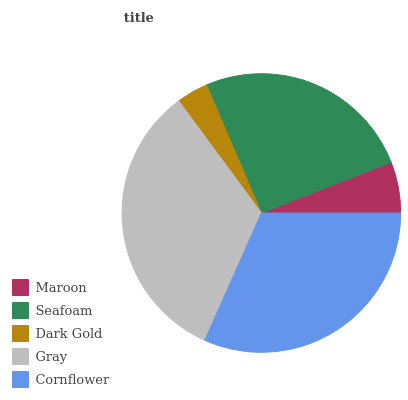Is Dark Gold the minimum?
Answer yes or no. Yes. Is Gray the maximum?
Answer yes or no. Yes. Is Seafoam the minimum?
Answer yes or no. No. Is Seafoam the maximum?
Answer yes or no. No. Is Seafoam greater than Maroon?
Answer yes or no. Yes. Is Maroon less than Seafoam?
Answer yes or no. Yes. Is Maroon greater than Seafoam?
Answer yes or no. No. Is Seafoam less than Maroon?
Answer yes or no. No. Is Seafoam the high median?
Answer yes or no. Yes. Is Seafoam the low median?
Answer yes or no. Yes. Is Cornflower the high median?
Answer yes or no. No. Is Gray the low median?
Answer yes or no. No. 